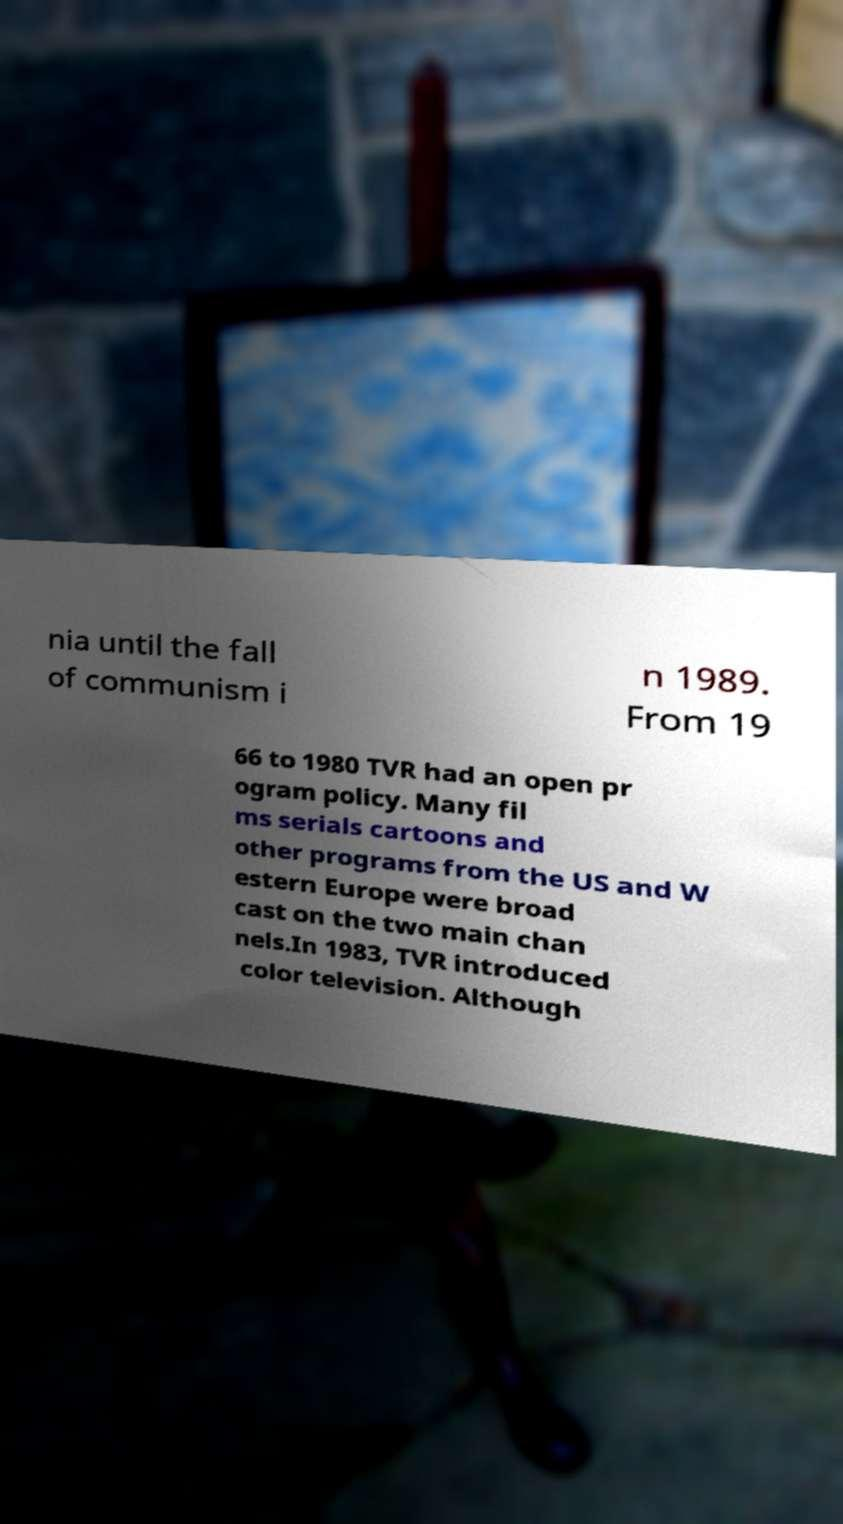Could you extract and type out the text from this image? nia until the fall of communism i n 1989. From 19 66 to 1980 TVR had an open pr ogram policy. Many fil ms serials cartoons and other programs from the US and W estern Europe were broad cast on the two main chan nels.In 1983, TVR introduced color television. Although 